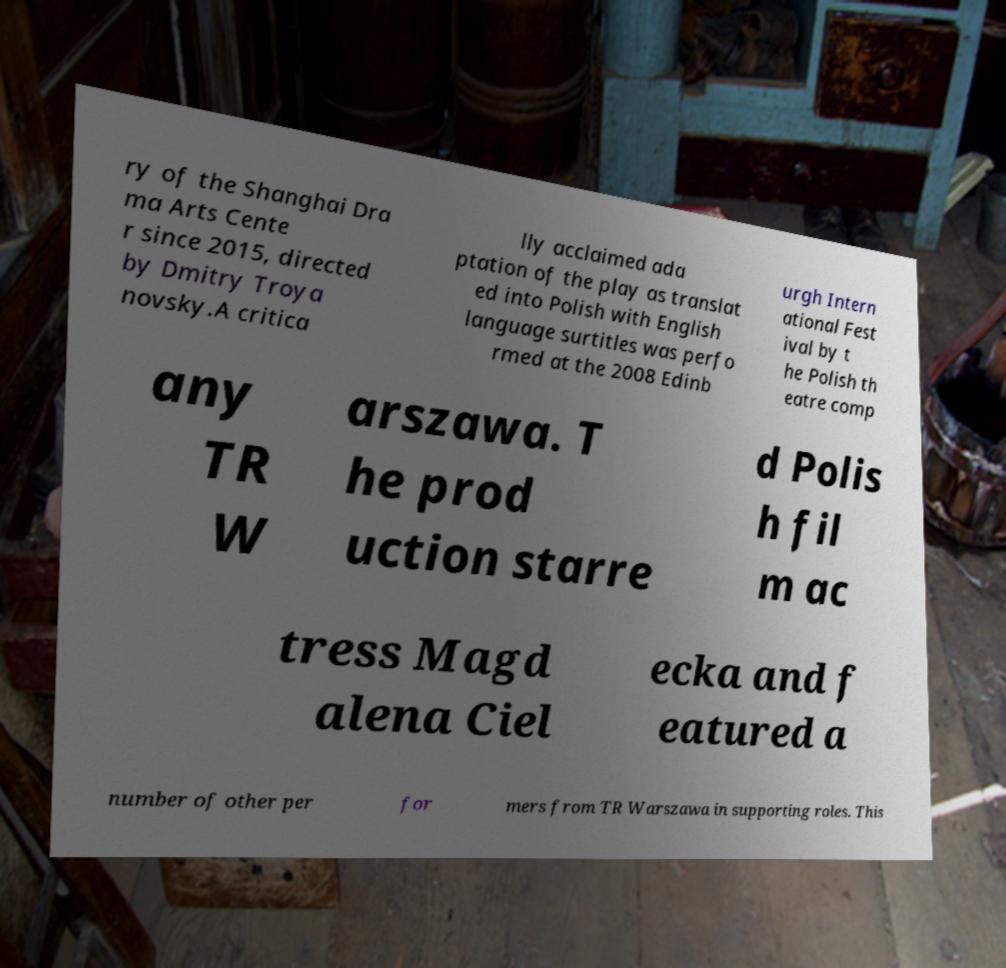Can you read and provide the text displayed in the image?This photo seems to have some interesting text. Can you extract and type it out for me? ry of the Shanghai Dra ma Arts Cente r since 2015, directed by Dmitry Troya novsky.A critica lly acclaimed ada ptation of the play as translat ed into Polish with English language surtitles was perfo rmed at the 2008 Edinb urgh Intern ational Fest ival by t he Polish th eatre comp any TR W arszawa. T he prod uction starre d Polis h fil m ac tress Magd alena Ciel ecka and f eatured a number of other per for mers from TR Warszawa in supporting roles. This 